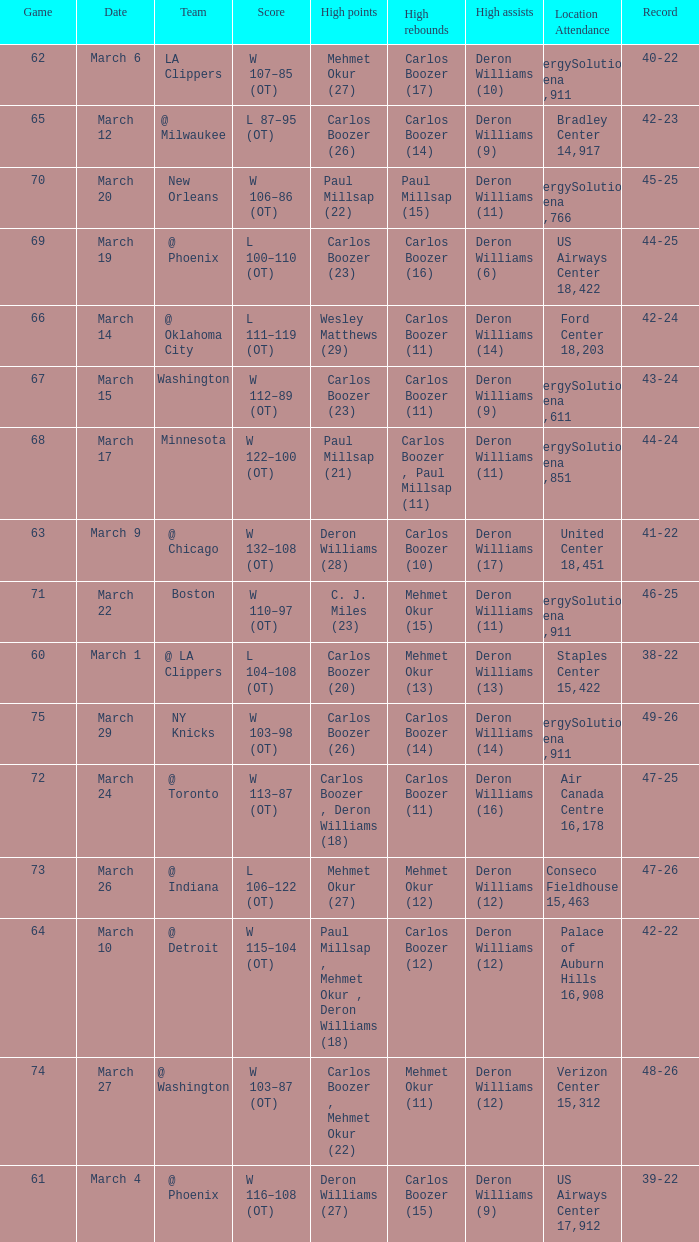What was the record at the game where Deron Williams (6) did the high assists? 44-25. 